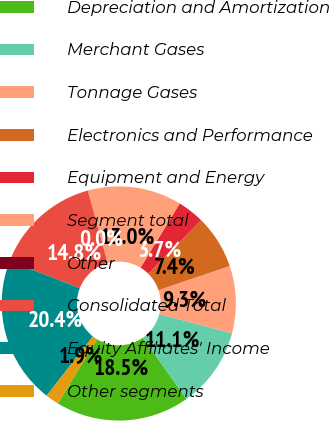Convert chart to OTSL. <chart><loc_0><loc_0><loc_500><loc_500><pie_chart><fcel>Depreciation and Amortization<fcel>Merchant Gases<fcel>Tonnage Gases<fcel>Electronics and Performance<fcel>Equipment and Energy<fcel>Segment total<fcel>Other<fcel>Consolidated Total<fcel>Equity Affiliates' Income<fcel>Other segments<nl><fcel>18.51%<fcel>11.11%<fcel>9.26%<fcel>7.41%<fcel>3.71%<fcel>12.96%<fcel>0.01%<fcel>14.81%<fcel>20.36%<fcel>1.86%<nl></chart> 